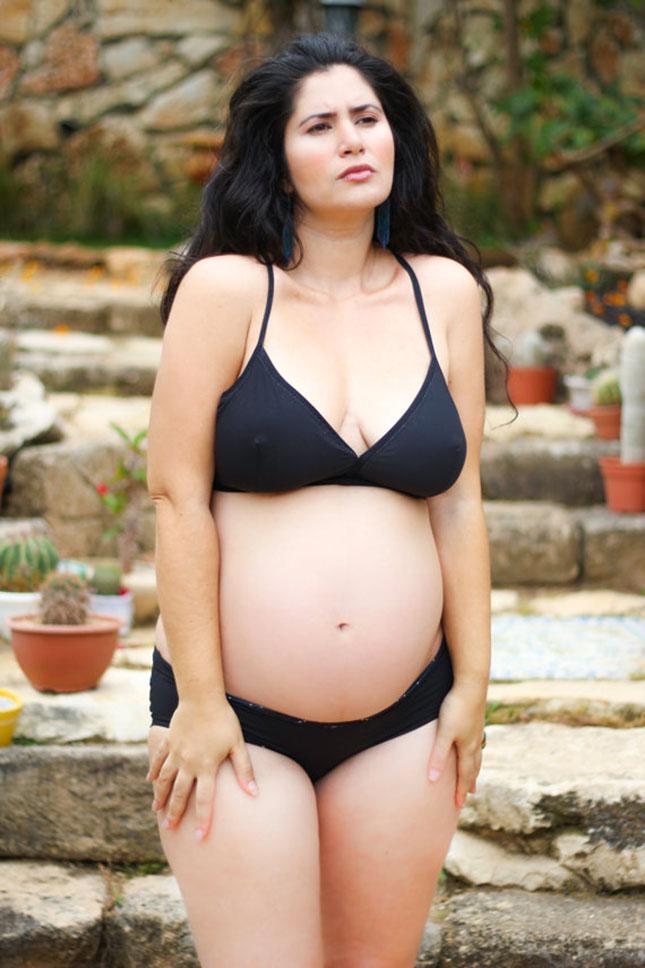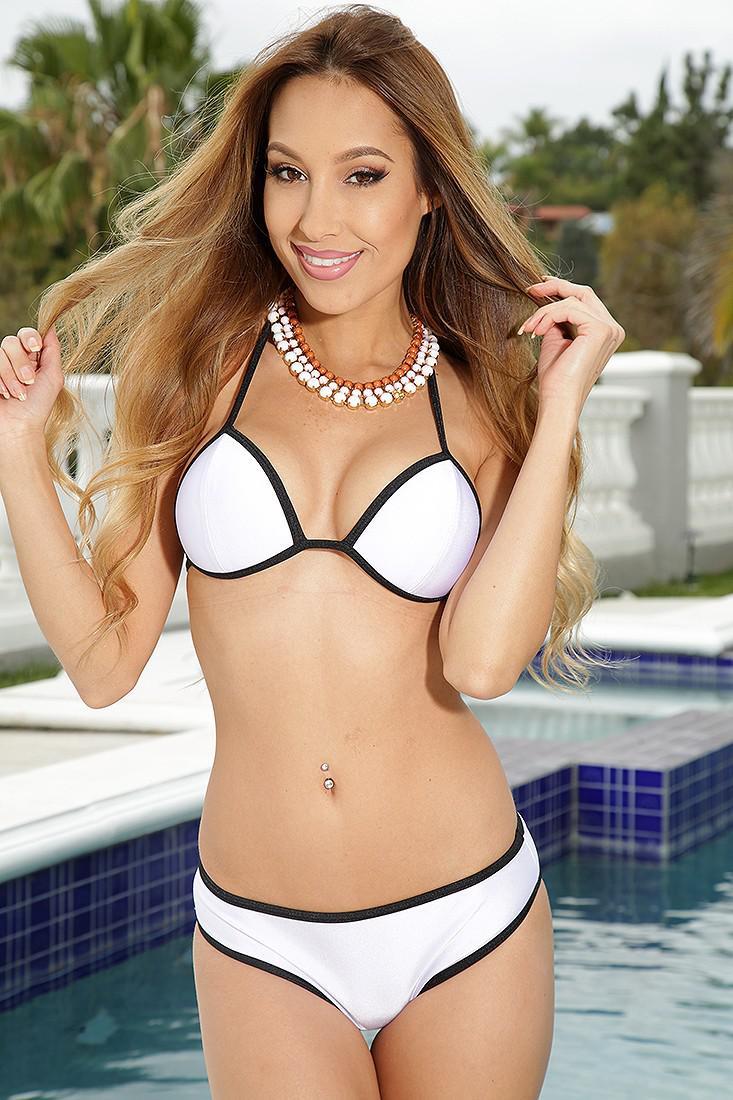The first image is the image on the left, the second image is the image on the right. Examine the images to the left and right. Is the description "The woman in the image on the right is wearing a white bikini." accurate? Answer yes or no. Yes. The first image is the image on the left, the second image is the image on the right. Given the left and right images, does the statement "There is a woman with at least one of her hands touching her hair." hold true? Answer yes or no. Yes. 